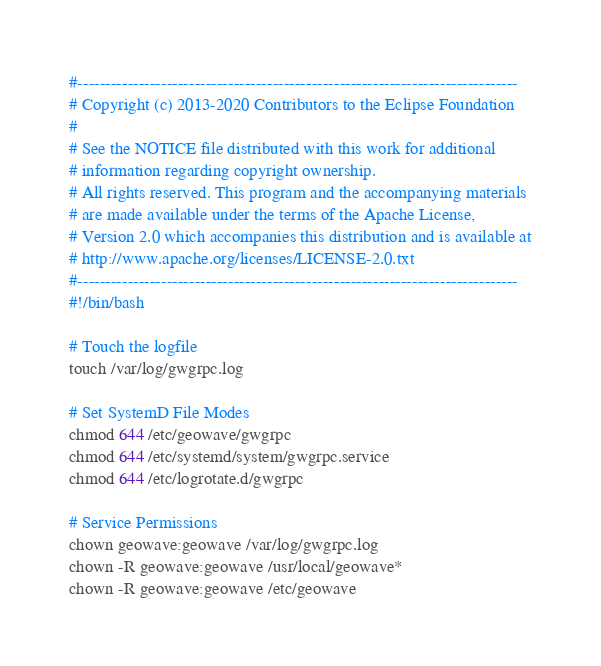<code> <loc_0><loc_0><loc_500><loc_500><_Bash_>#-------------------------------------------------------------------------------
# Copyright (c) 2013-2020 Contributors to the Eclipse Foundation
# 
# See the NOTICE file distributed with this work for additional
# information regarding copyright ownership.
# All rights reserved. This program and the accompanying materials
# are made available under the terms of the Apache License,
# Version 2.0 which accompanies this distribution and is available at
# http://www.apache.org/licenses/LICENSE-2.0.txt
#-------------------------------------------------------------------------------
#!/bin/bash

# Touch the logfile
touch /var/log/gwgrpc.log

# Set SystemD File Modes
chmod 644 /etc/geowave/gwgrpc
chmod 644 /etc/systemd/system/gwgrpc.service
chmod 644 /etc/logrotate.d/gwgrpc

# Service Permissions
chown geowave:geowave /var/log/gwgrpc.log
chown -R geowave:geowave /usr/local/geowave*
chown -R geowave:geowave /etc/geowave
</code> 